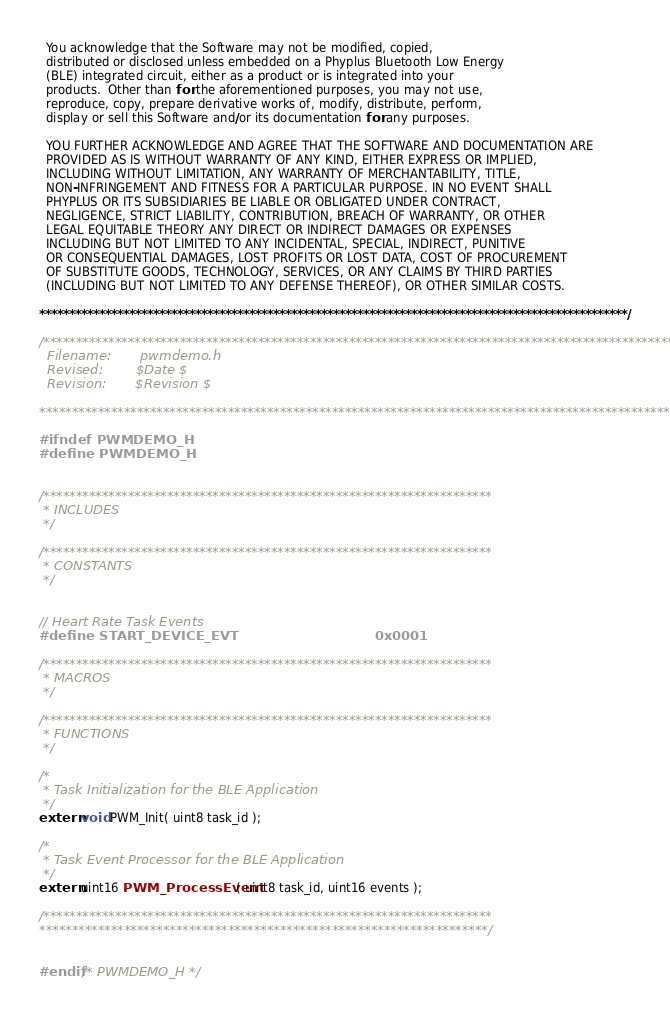Convert code to text. <code><loc_0><loc_0><loc_500><loc_500><_C_>  You acknowledge that the Software may not be modified, copied, 
  distributed or disclosed unless embedded on a Phyplus Bluetooth Low Energy 
  (BLE) integrated circuit, either as a product or is integrated into your 
  products.  Other than for the aforementioned purposes, you may not use, 
  reproduce, copy, prepare derivative works of, modify, distribute, perform, 
  display or sell this Software and/or its documentation for any purposes.

  YOU FURTHER ACKNOWLEDGE AND AGREE THAT THE SOFTWARE AND DOCUMENTATION ARE
  PROVIDED AS IS WITHOUT WARRANTY OF ANY KIND, EITHER EXPRESS OR IMPLIED,
  INCLUDING WITHOUT LIMITATION, ANY WARRANTY OF MERCHANTABILITY, TITLE,
  NON-INFRINGEMENT AND FITNESS FOR A PARTICULAR PURPOSE. IN NO EVENT SHALL
  PHYPLUS OR ITS SUBSIDIARIES BE LIABLE OR OBLIGATED UNDER CONTRACT,
  NEGLIGENCE, STRICT LIABILITY, CONTRIBUTION, BREACH OF WARRANTY, OR OTHER
  LEGAL EQUITABLE THEORY ANY DIRECT OR INDIRECT DAMAGES OR EXPENSES
  INCLUDING BUT NOT LIMITED TO ANY INCIDENTAL, SPECIAL, INDIRECT, PUNITIVE
  OR CONSEQUENTIAL DAMAGES, LOST PROFITS OR LOST DATA, COST OF PROCUREMENT
  OF SUBSTITUTE GOODS, TECHNOLOGY, SERVICES, OR ANY CLAIMS BY THIRD PARTIES
  (INCLUDING BUT NOT LIMITED TO ANY DEFENSE THEREOF), OR OTHER SIMILAR COSTS.
  
**************************************************************************************************/

/**************************************************************************************************
  Filename:       pwmdemo.h
  Revised:        $Date $
  Revision:       $Revision $

**************************************************************************************************/

#ifndef PWMDEMO_H
#define PWMDEMO_H


/*********************************************************************
 * INCLUDES
 */

/*********************************************************************
 * CONSTANTS
 */


// Heart Rate Task Events
#define START_DEVICE_EVT                              0x0001

/*********************************************************************
 * MACROS
 */

/*********************************************************************
 * FUNCTIONS
 */

/*
 * Task Initialization for the BLE Application
 */
extern void PWM_Init( uint8 task_id );

/*
 * Task Event Processor for the BLE Application
 */
extern uint16 PWM_ProcessEvent( uint8 task_id, uint16 events );

/*********************************************************************
*********************************************************************/


#endif /* PWMDEMO_H */
</code> 